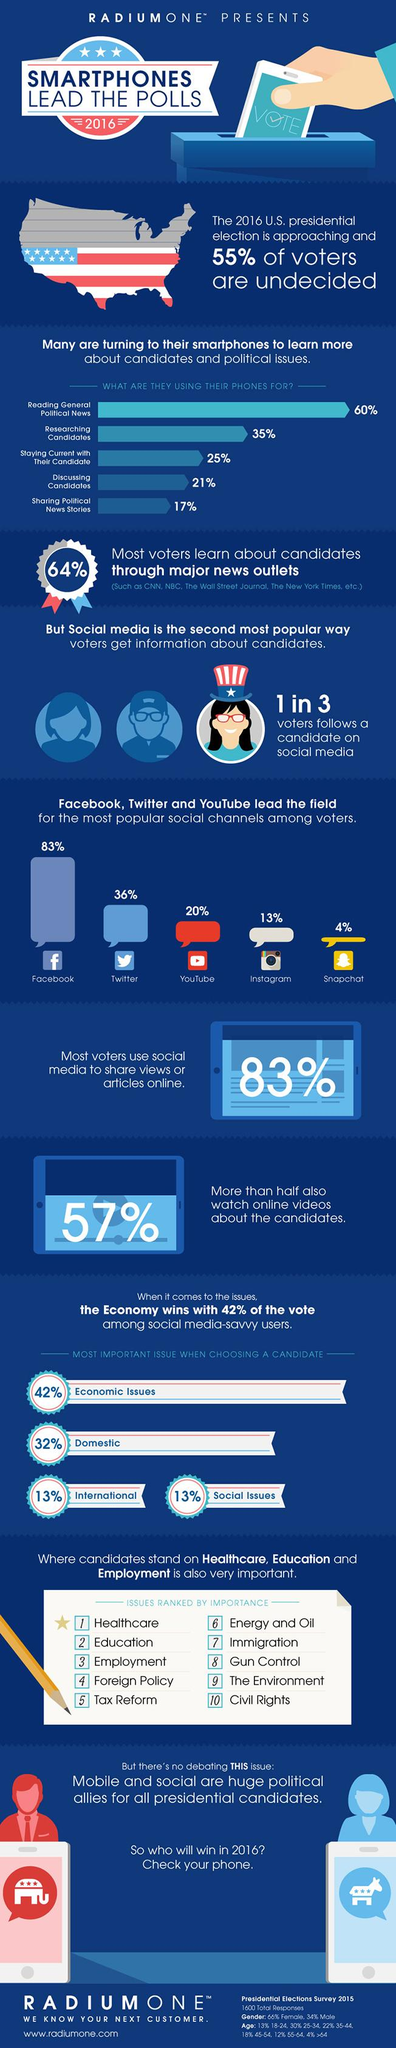Give some essential details in this illustration. Seventy-seven percent of people are using their smartphones for reading general political news and sharing political news stories, according to a recent survey. According to the survey, 56% of the respondents are using their smartphones for both researching candidates and discussing candidates, taken together. According to a survey, 36% of voters learn about candidates primarily through sources other than major news outlets. According to the given data, 17% of voters did not use social media to share their views or articles online. Of the three candidates, two did not follow each other on social media. 